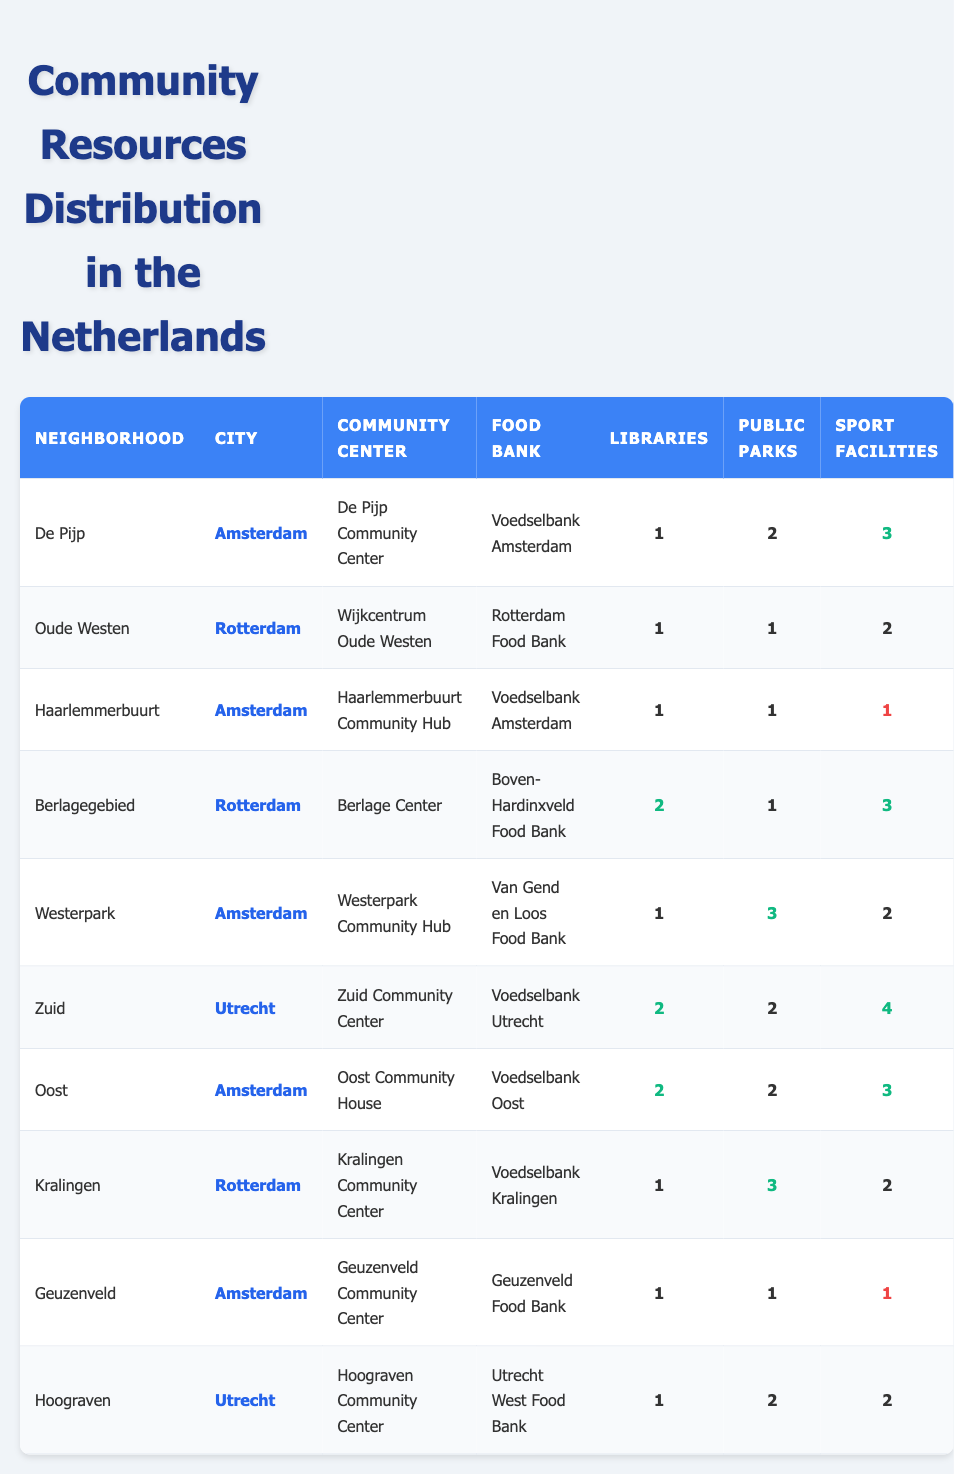What is the name of the community center in De Pijp? The table lists "De Pijp Community Center" under the "Community Center" column for the neighborhood De Pijp.
Answer: De Pijp Community Center How many public parks are available in the neighborhood of Zuid? The table shows "2" under the "Public Parks" column for the neighborhood Zuid.
Answer: 2 Which neighborhood has the highest number of sport facilities? By comparing the "Sport Facilities" column, Zuid has "4," which is the highest number among all neighborhoods.
Answer: Zuid Is there a food bank available in Haarlemmerbuurt? The table indicates there is a food bank called "Voedselbank Amsterdam" available in Haarlemmerbuurt.
Answer: Yes How many libraries are there in Kralingen? The table indicates "1" library available in Kralingen under the "Libraries" column.
Answer: 1 Which neighborhood in Utrecht has the most community resources based on sport facilities and public parks? In Zuid, there are 2 public parks and 4 sport facilities, while in Hoograven, there are 2 public parks and 2 sport facilities. Zuid has the highest total of sport facilities.
Answer: Zuid What is the total number of libraries across all neighborhoods in Amsterdam? The libraries in Amsterdam are: De Pijp (1), Haarlemmerbuurt (1), Westerpark (1), Oost (2), and Geuzenveld (1). Adding these gives 1 + 1 + 1 + 2 + 1 = 6 libraries.
Answer: 6 Which neighborhood has the least number of sport facilities, and what is that number? By inspecting the "Sport Facilities" column, Haarlemmerbuurt and Geuzenveld both have "1," which is the lowest count.
Answer: Haarlemmerbuurt and Geuzenveld, 1 Is it true that all neighborhoods in Utrecht have a community center? The table shows that both Zuid and Hoograven have community centers listed, confirming that it's true.
Answer: Yes What is the difference in the number of public parks between Berlagegebied and Kralingen? Berlagegebied has "1" public park and Kralingen has "3". The difference is 3 - 1 = 2.
Answer: 2 Which city has the most neighborhoods represented in the table? Amsterdam is represented by 5 neighborhoods (De Pijp, Haarlemmerbuurt, Westerpark, Oost, Geuzenveld) while Rotterdam has 3 and Utrecht has 2.
Answer: Amsterdam 